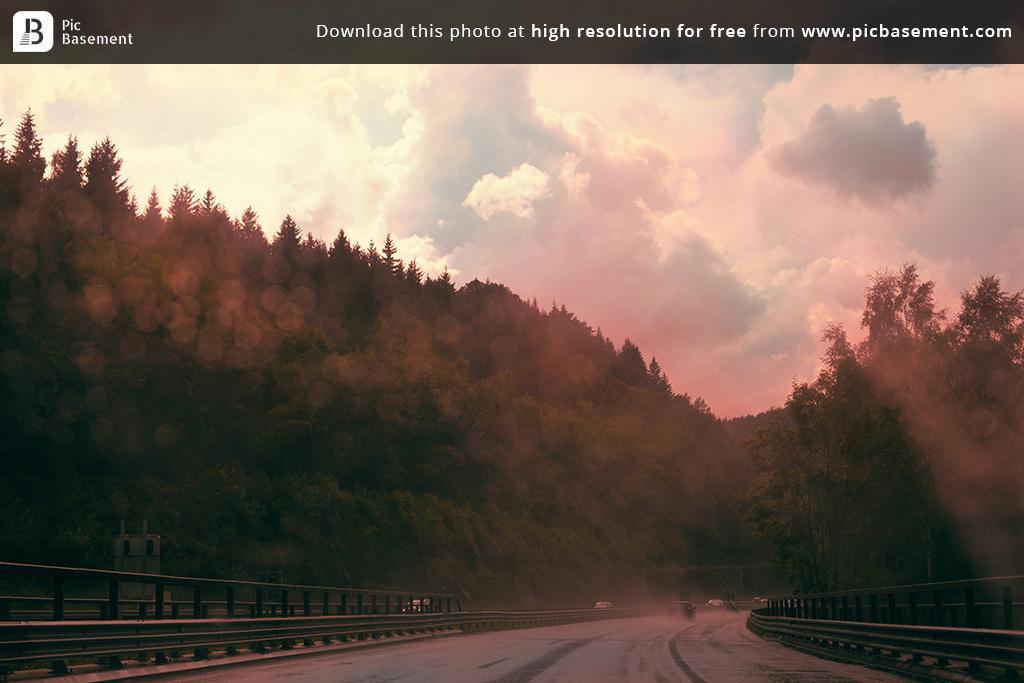Could you give a brief overview of what you see in this image? In this image at the bottom there is a road on the road there are some vehicles, and on the right side and left side there is a fence. And in the background there are some trees, on the top of the image there is sky and some text. 